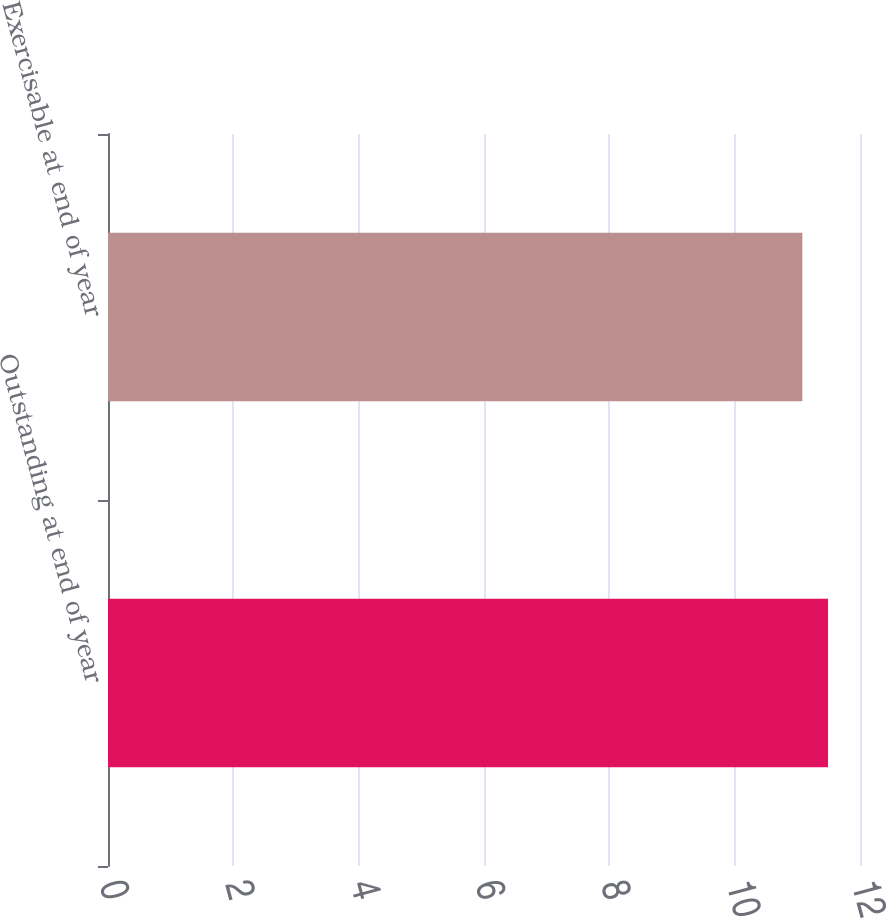Convert chart. <chart><loc_0><loc_0><loc_500><loc_500><bar_chart><fcel>Outstanding at end of year<fcel>Exercisable at end of year<nl><fcel>11.49<fcel>11.08<nl></chart> 